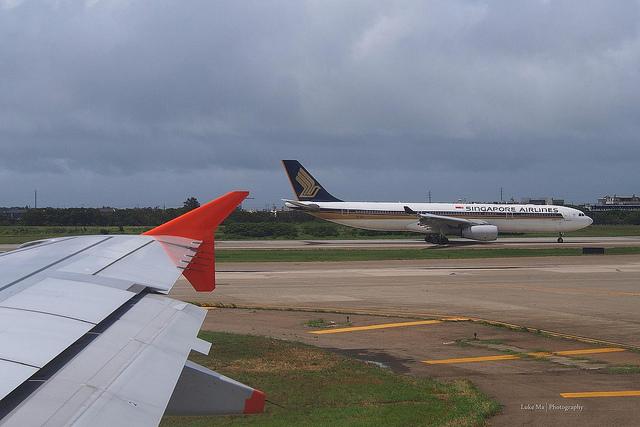Is the plane in the air?
Keep it brief. No. Is this a fighter jet?
Answer briefly. No. Is this a passenger plane?
Write a very short answer. Yes. How many planes are on the ground?
Keep it brief. 2. Does the weather look bad enough to ground the planes?
Write a very short answer. No. What color is the planes wing?
Short answer required. White. Could more than 100 people ride on this?
Keep it brief. Yes. 